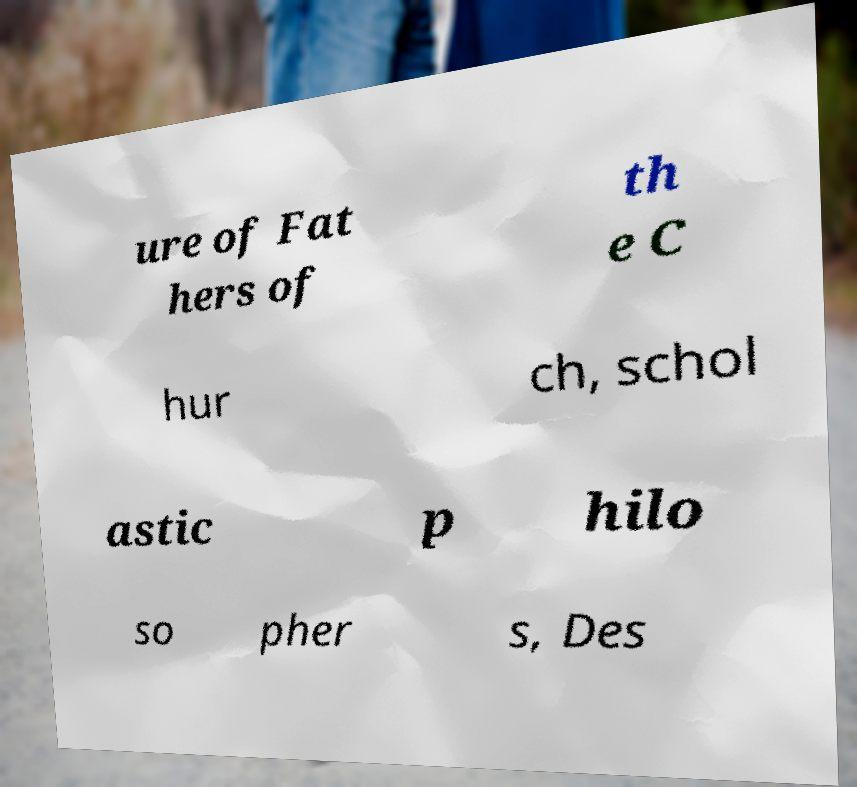What messages or text are displayed in this image? I need them in a readable, typed format. ure of Fat hers of th e C hur ch, schol astic p hilo so pher s, Des 